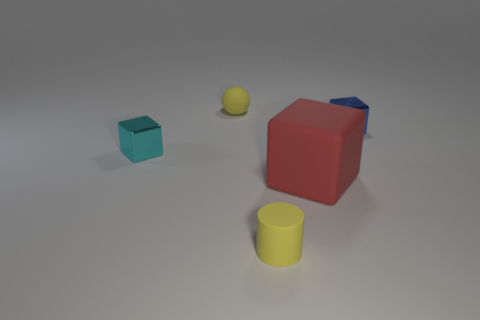Add 3 large green matte blocks. How many objects exist? 8 Subtract all spheres. How many objects are left? 4 Subtract all small purple rubber blocks. Subtract all cyan metallic cubes. How many objects are left? 4 Add 3 tiny blue blocks. How many tiny blue blocks are left? 4 Add 4 tiny yellow cylinders. How many tiny yellow cylinders exist? 5 Subtract 0 cyan cylinders. How many objects are left? 5 